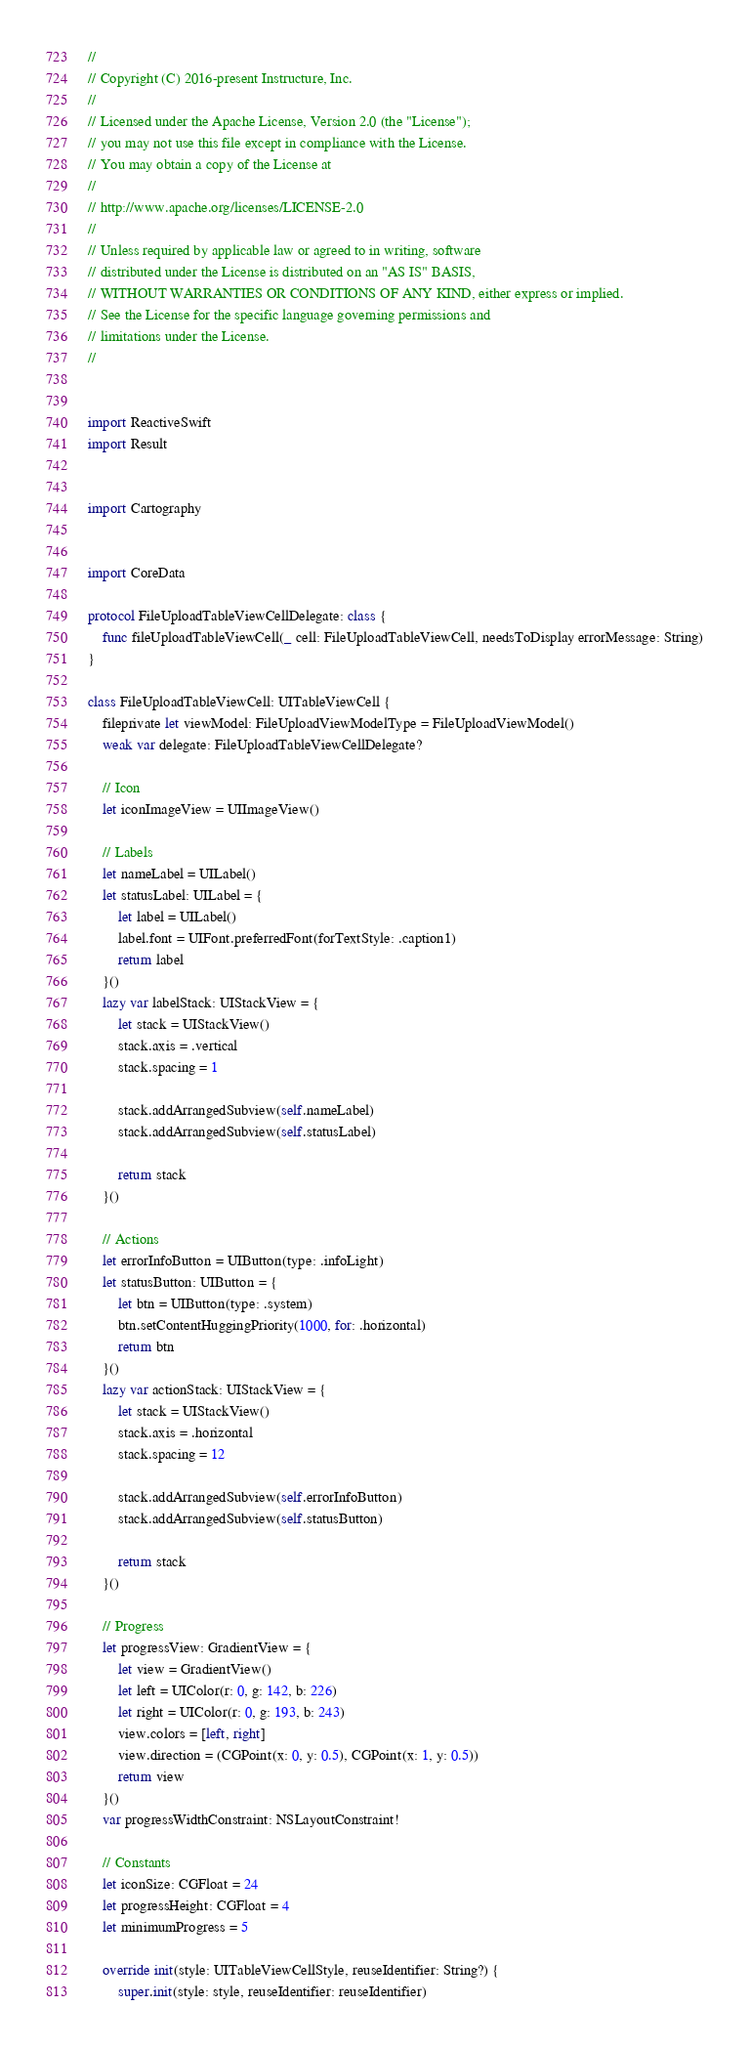Convert code to text. <code><loc_0><loc_0><loc_500><loc_500><_Swift_>//
// Copyright (C) 2016-present Instructure, Inc.
//
// Licensed under the Apache License, Version 2.0 (the "License");
// you may not use this file except in compliance with the License.
// You may obtain a copy of the License at
//
// http://www.apache.org/licenses/LICENSE-2.0
//
// Unless required by applicable law or agreed to in writing, software
// distributed under the License is distributed on an "AS IS" BASIS,
// WITHOUT WARRANTIES OR CONDITIONS OF ANY KIND, either express or implied.
// See the License for the specific language governing permissions and
// limitations under the License.
//


import ReactiveSwift
import Result


import Cartography


import CoreData

protocol FileUploadTableViewCellDelegate: class {
    func fileUploadTableViewCell(_ cell: FileUploadTableViewCell, needsToDisplay errorMessage: String)
}

class FileUploadTableViewCell: UITableViewCell {
    fileprivate let viewModel: FileUploadViewModelType = FileUploadViewModel()
    weak var delegate: FileUploadTableViewCellDelegate?

    // Icon
    let iconImageView = UIImageView()

    // Labels
    let nameLabel = UILabel()
    let statusLabel: UILabel = {
        let label = UILabel()
        label.font = UIFont.preferredFont(forTextStyle: .caption1)
        return label
    }()
    lazy var labelStack: UIStackView = {
        let stack = UIStackView()
        stack.axis = .vertical
        stack.spacing = 1

        stack.addArrangedSubview(self.nameLabel)
        stack.addArrangedSubview(self.statusLabel)

        return stack
    }()

    // Actions
    let errorInfoButton = UIButton(type: .infoLight)
    let statusButton: UIButton = {
        let btn = UIButton(type: .system)
        btn.setContentHuggingPriority(1000, for: .horizontal)
        return btn
    }()
    lazy var actionStack: UIStackView = {
        let stack = UIStackView()
        stack.axis = .horizontal
        stack.spacing = 12

        stack.addArrangedSubview(self.errorInfoButton)
        stack.addArrangedSubview(self.statusButton)

        return stack
    }()

    // Progress
    let progressView: GradientView = {
        let view = GradientView()
        let left = UIColor(r: 0, g: 142, b: 226)
        let right = UIColor(r: 0, g: 193, b: 243)
        view.colors = [left, right]
        view.direction = (CGPoint(x: 0, y: 0.5), CGPoint(x: 1, y: 0.5))
        return view
    }()
    var progressWidthConstraint: NSLayoutConstraint!

    // Constants
    let iconSize: CGFloat = 24
    let progressHeight: CGFloat = 4
    let minimumProgress = 5

    override init(style: UITableViewCellStyle, reuseIdentifier: String?) {
        super.init(style: style, reuseIdentifier: reuseIdentifier)
</code> 